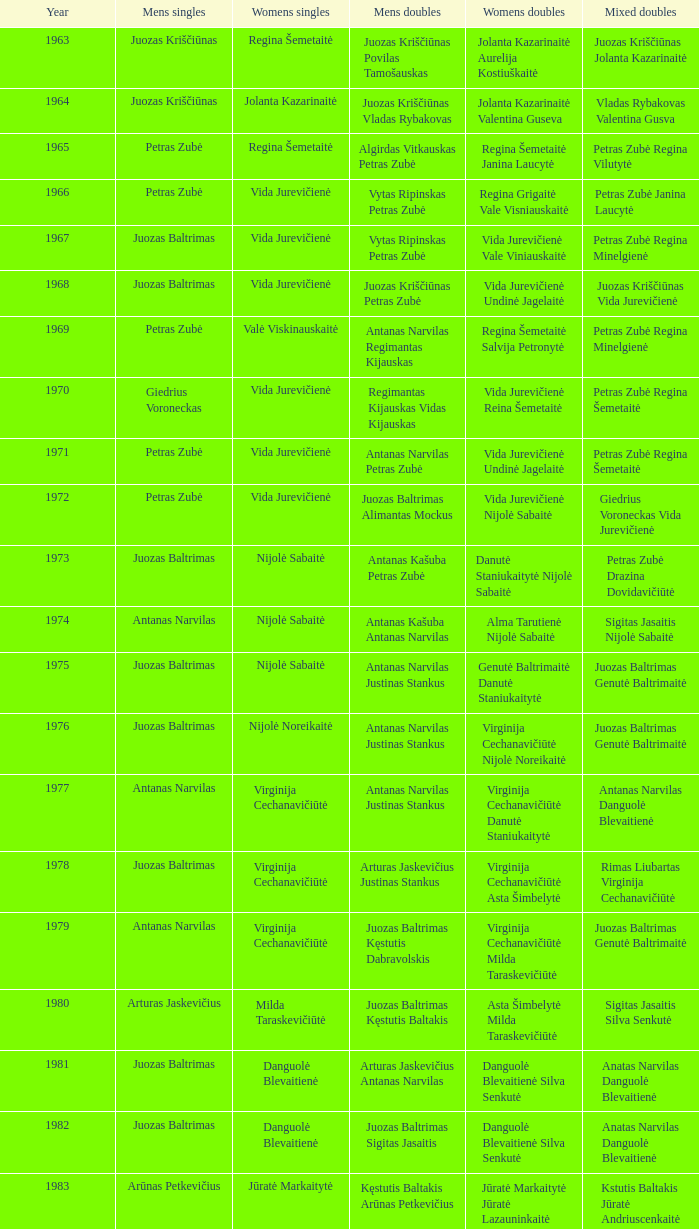What was the debut year of the lithuanian national badminton championships? 1963.0. 